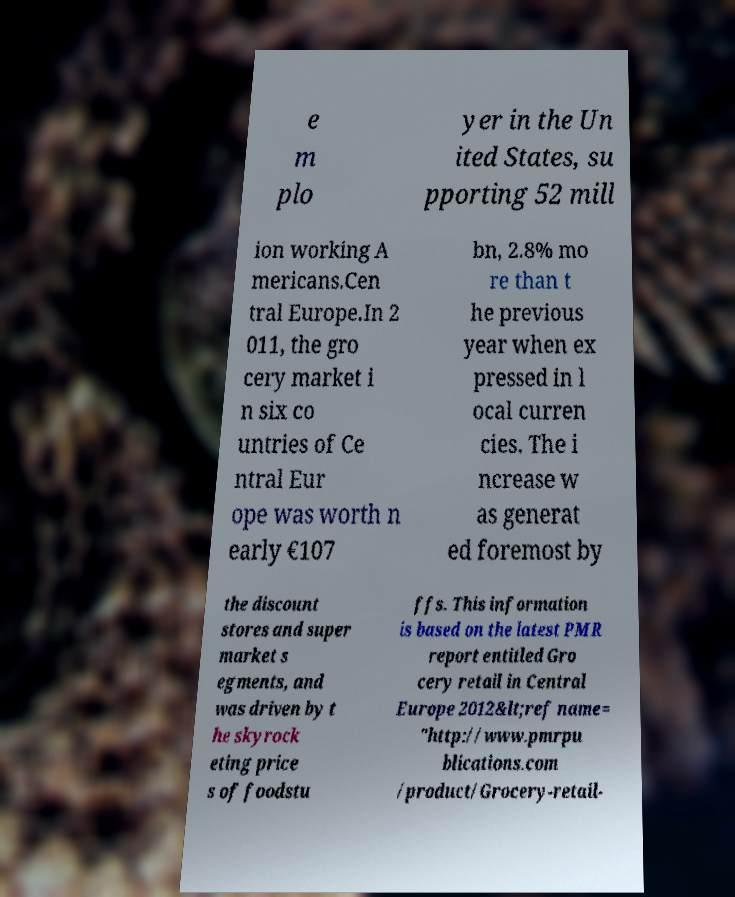Can you accurately transcribe the text from the provided image for me? e m plo yer in the Un ited States, su pporting 52 mill ion working A mericans.Cen tral Europe.In 2 011, the gro cery market i n six co untries of Ce ntral Eur ope was worth n early €107 bn, 2.8% mo re than t he previous year when ex pressed in l ocal curren cies. The i ncrease w as generat ed foremost by the discount stores and super market s egments, and was driven by t he skyrock eting price s of foodstu ffs. This information is based on the latest PMR report entitled Gro cery retail in Central Europe 2012&lt;ref name= "http://www.pmrpu blications.com /product/Grocery-retail- 